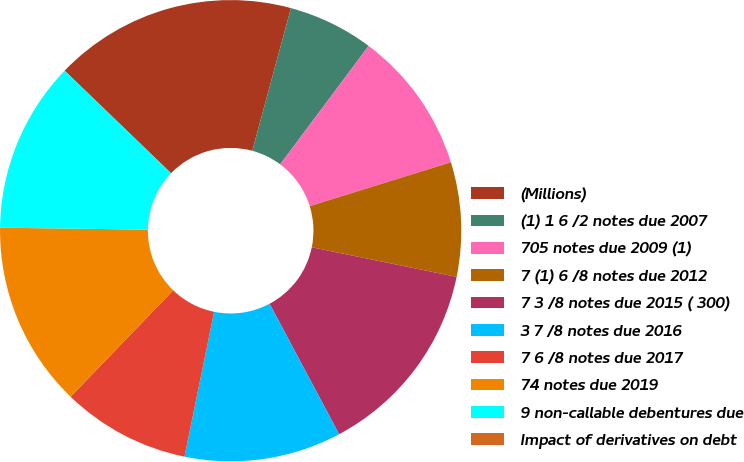Convert chart. <chart><loc_0><loc_0><loc_500><loc_500><pie_chart><fcel>(Millions)<fcel>(1) 1 6 /2 notes due 2007<fcel>705 notes due 2009 (1)<fcel>7 (1) 6 /8 notes due 2012<fcel>7 3 /8 notes due 2015 ( 300)<fcel>3 7 /8 notes due 2016<fcel>7 6 /8 notes due 2017<fcel>74 notes due 2019<fcel>9 non-callable debentures due<fcel>Impact of derivatives on debt<nl><fcel>17.0%<fcel>6.0%<fcel>10.0%<fcel>8.0%<fcel>14.0%<fcel>11.0%<fcel>9.0%<fcel>13.0%<fcel>12.0%<fcel>0.0%<nl></chart> 